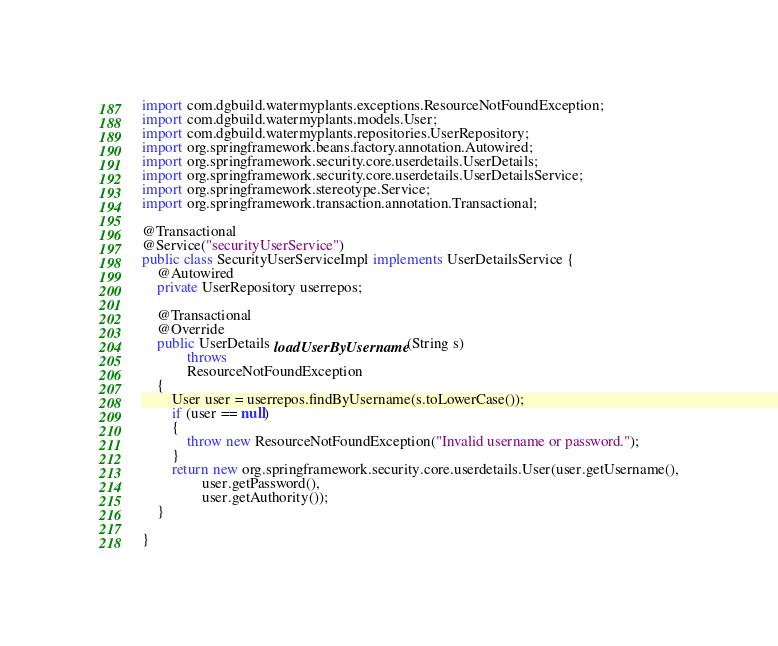<code> <loc_0><loc_0><loc_500><loc_500><_Java_>import com.dgbuild.watermyplants.exceptions.ResourceNotFoundException;
import com.dgbuild.watermyplants.models.User;
import com.dgbuild.watermyplants.repositories.UserRepository;
import org.springframework.beans.factory.annotation.Autowired;
import org.springframework.security.core.userdetails.UserDetails;
import org.springframework.security.core.userdetails.UserDetailsService;
import org.springframework.stereotype.Service;
import org.springframework.transaction.annotation.Transactional;

@Transactional
@Service("securityUserService")
public class SecurityUserServiceImpl implements UserDetailsService {
    @Autowired
    private UserRepository userrepos;

    @Transactional
    @Override
    public UserDetails loadUserByUsername(String s)
            throws
            ResourceNotFoundException
    {
        User user = userrepos.findByUsername(s.toLowerCase());
        if (user == null)
        {
            throw new ResourceNotFoundException("Invalid username or password.");
        }
        return new org.springframework.security.core.userdetails.User(user.getUsername(),
                user.getPassword(),
                user.getAuthority());
    }

}
</code> 